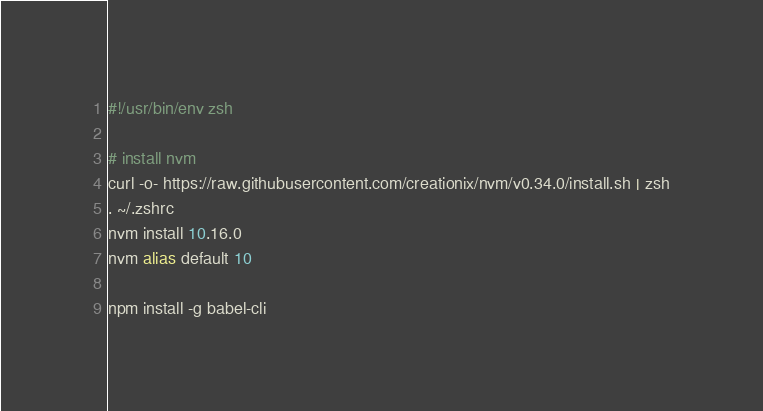<code> <loc_0><loc_0><loc_500><loc_500><_Bash_>#!/usr/bin/env zsh

# install nvm
curl -o- https://raw.githubusercontent.com/creationix/nvm/v0.34.0/install.sh | zsh
. ~/.zshrc
nvm install 10.16.0
nvm alias default 10

npm install -g babel-cli
</code> 